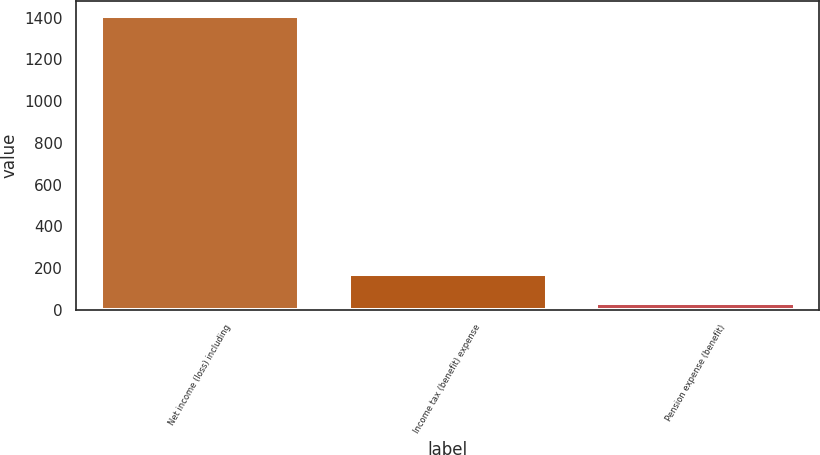Convert chart. <chart><loc_0><loc_0><loc_500><loc_500><bar_chart><fcel>Net income (loss) including<fcel>Income tax (benefit) expense<fcel>Pension expense (benefit)<nl><fcel>1407.2<fcel>169.79<fcel>32.3<nl></chart> 